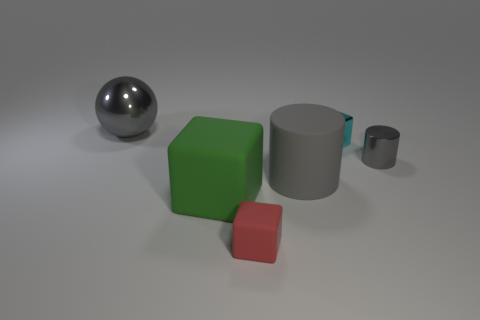Subtract all matte blocks. How many blocks are left? 1 Subtract all red cubes. How many cubes are left? 2 Subtract 1 cylinders. How many cylinders are left? 1 Add 3 small metallic cylinders. How many objects exist? 9 Subtract all gray cylinders. How many purple balls are left? 0 Subtract all cylinders. How many objects are left? 4 Subtract all large gray rubber things. Subtract all yellow matte cylinders. How many objects are left? 5 Add 6 small metallic blocks. How many small metallic blocks are left? 7 Add 3 tiny red matte cylinders. How many tiny red matte cylinders exist? 3 Subtract 0 yellow cubes. How many objects are left? 6 